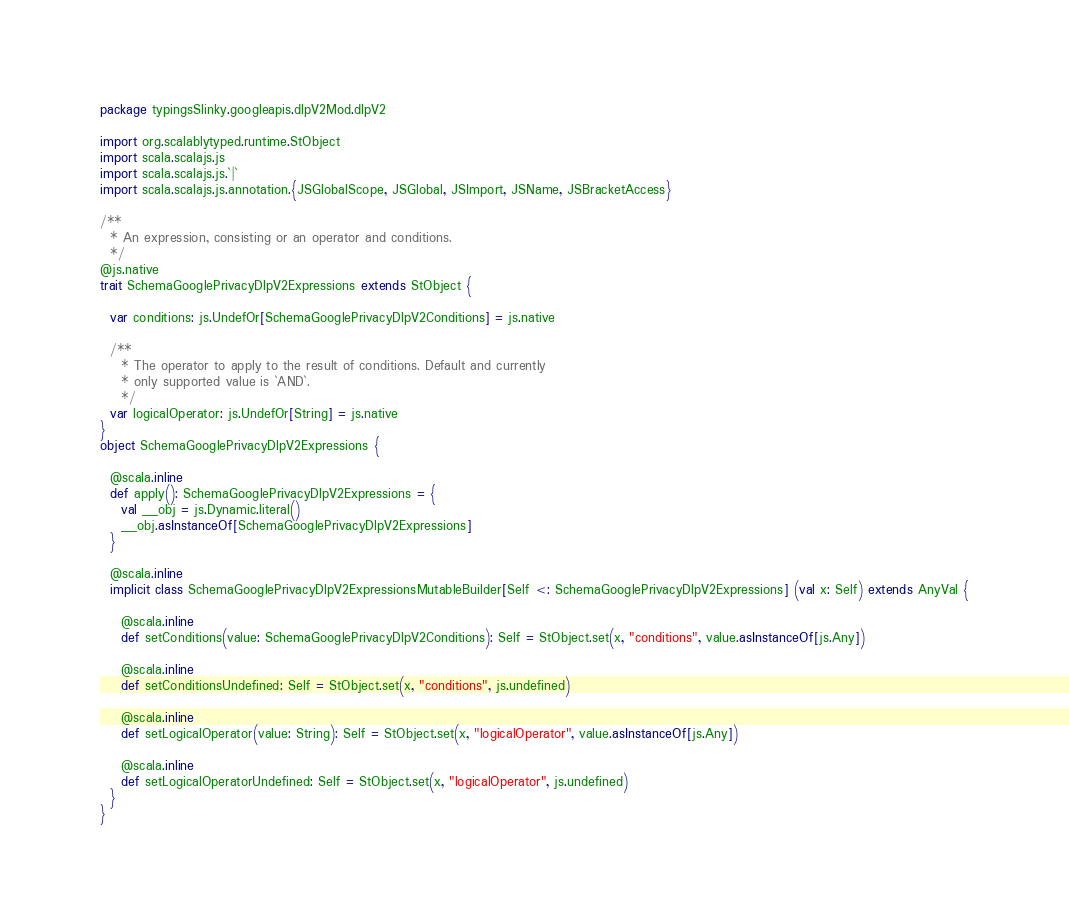<code> <loc_0><loc_0><loc_500><loc_500><_Scala_>package typingsSlinky.googleapis.dlpV2Mod.dlpV2

import org.scalablytyped.runtime.StObject
import scala.scalajs.js
import scala.scalajs.js.`|`
import scala.scalajs.js.annotation.{JSGlobalScope, JSGlobal, JSImport, JSName, JSBracketAccess}

/**
  * An expression, consisting or an operator and conditions.
  */
@js.native
trait SchemaGooglePrivacyDlpV2Expressions extends StObject {
  
  var conditions: js.UndefOr[SchemaGooglePrivacyDlpV2Conditions] = js.native
  
  /**
    * The operator to apply to the result of conditions. Default and currently
    * only supported value is `AND`.
    */
  var logicalOperator: js.UndefOr[String] = js.native
}
object SchemaGooglePrivacyDlpV2Expressions {
  
  @scala.inline
  def apply(): SchemaGooglePrivacyDlpV2Expressions = {
    val __obj = js.Dynamic.literal()
    __obj.asInstanceOf[SchemaGooglePrivacyDlpV2Expressions]
  }
  
  @scala.inline
  implicit class SchemaGooglePrivacyDlpV2ExpressionsMutableBuilder[Self <: SchemaGooglePrivacyDlpV2Expressions] (val x: Self) extends AnyVal {
    
    @scala.inline
    def setConditions(value: SchemaGooglePrivacyDlpV2Conditions): Self = StObject.set(x, "conditions", value.asInstanceOf[js.Any])
    
    @scala.inline
    def setConditionsUndefined: Self = StObject.set(x, "conditions", js.undefined)
    
    @scala.inline
    def setLogicalOperator(value: String): Self = StObject.set(x, "logicalOperator", value.asInstanceOf[js.Any])
    
    @scala.inline
    def setLogicalOperatorUndefined: Self = StObject.set(x, "logicalOperator", js.undefined)
  }
}
</code> 